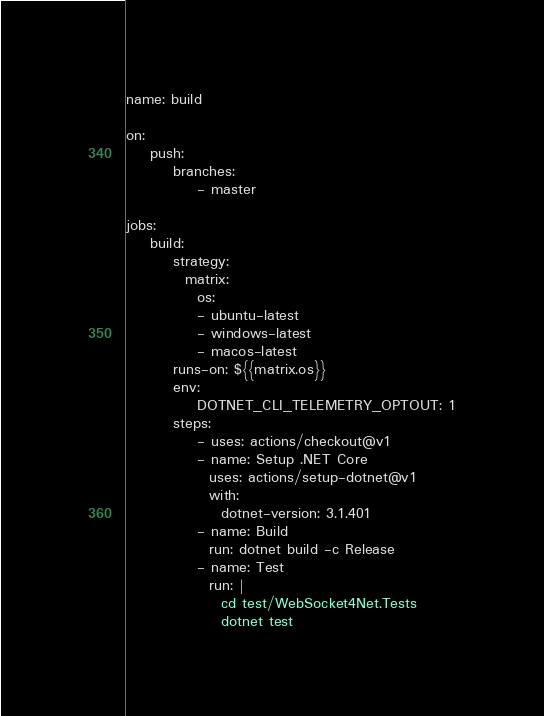Convert code to text. <code><loc_0><loc_0><loc_500><loc_500><_YAML_>name: build

on:
    push:
        branches:
            - master

jobs:
    build:
        strategy:
          matrix:
            os:
            - ubuntu-latest
            - windows-latest
            - macos-latest
        runs-on: ${{matrix.os}}
        env:
            DOTNET_CLI_TELEMETRY_OPTOUT: 1
        steps:
            - uses: actions/checkout@v1
            - name: Setup .NET Core
              uses: actions/setup-dotnet@v1
              with:
                dotnet-version: 3.1.401
            - name: Build
              run: dotnet build -c Release
            - name: Test
              run: |
                cd test/WebSocket4Net.Tests
                dotnet test</code> 